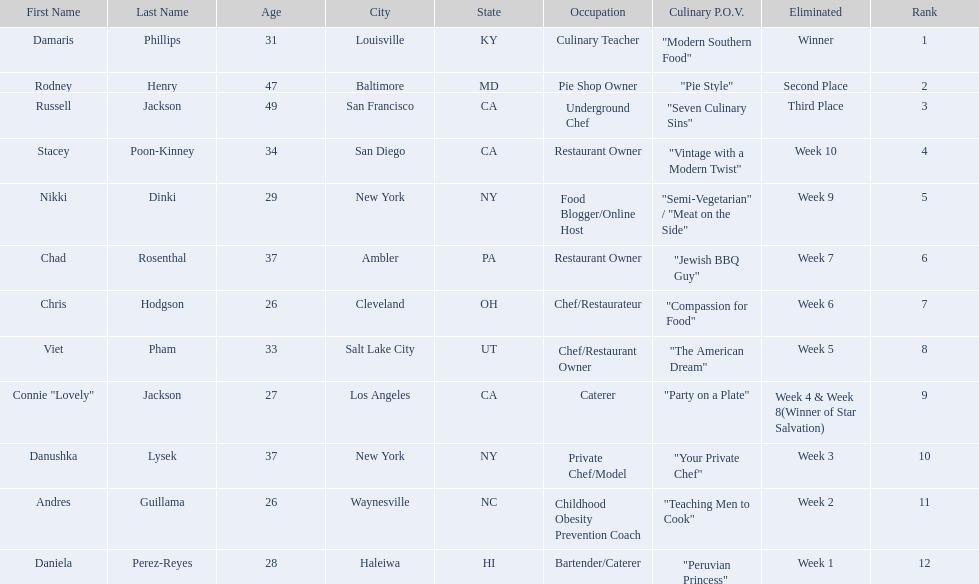Which food network star contestants are in their 20s? Nikki Dinki, Chris Hodgson, Connie "Lovely" Jackson, Andres Guillama, Daniela Perez-Reyes. Of these contestants, which one is the same age as chris hodgson? Andres Guillama. 